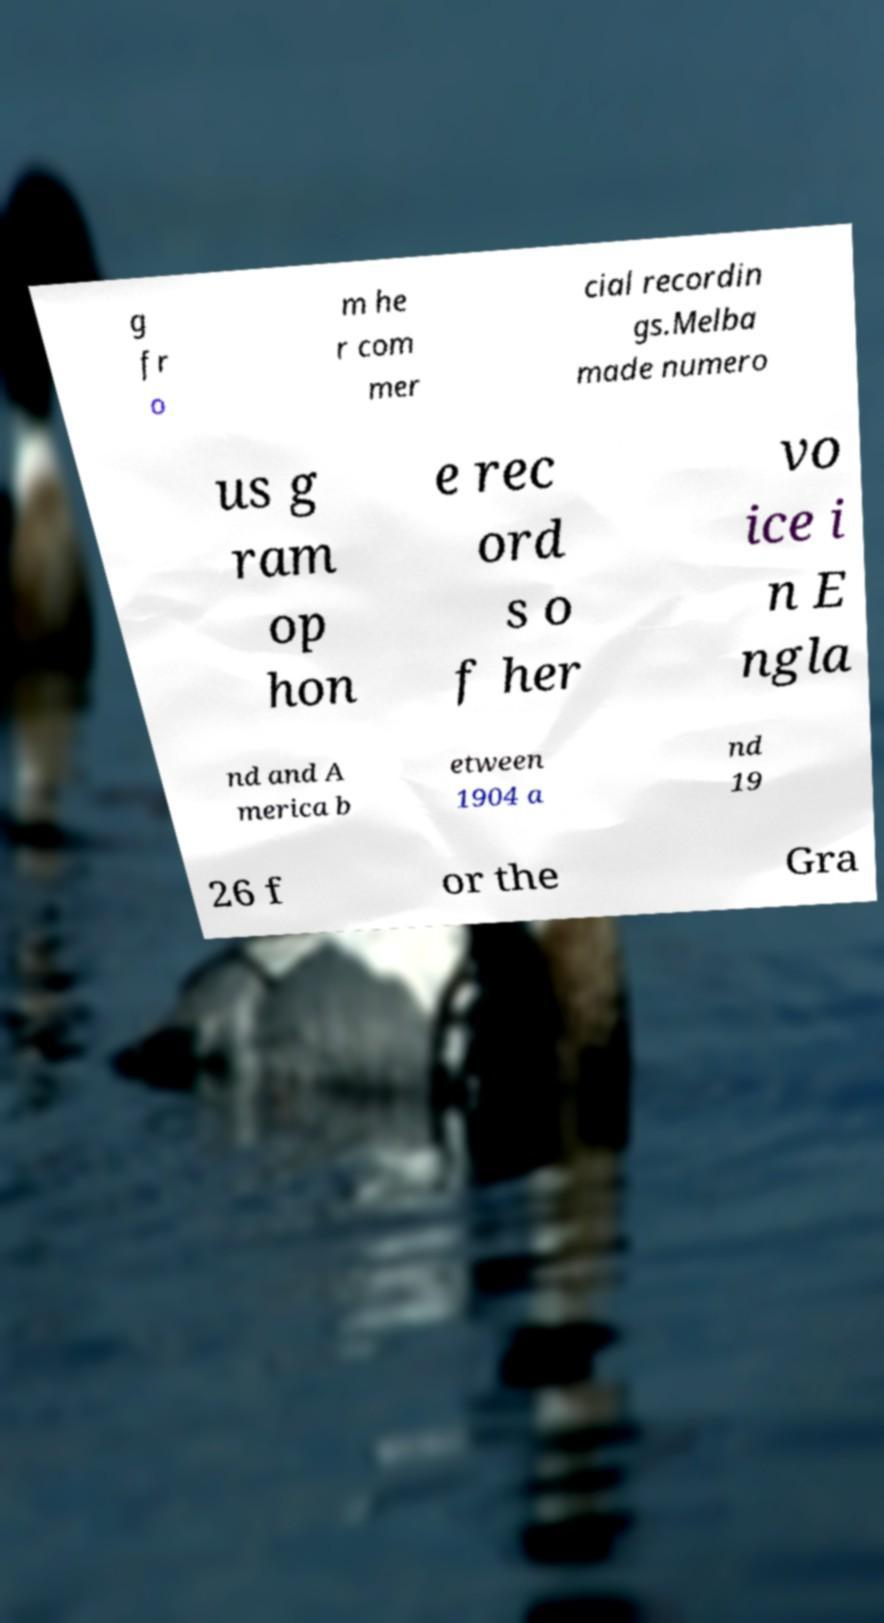I need the written content from this picture converted into text. Can you do that? g fr o m he r com mer cial recordin gs.Melba made numero us g ram op hon e rec ord s o f her vo ice i n E ngla nd and A merica b etween 1904 a nd 19 26 f or the Gra 